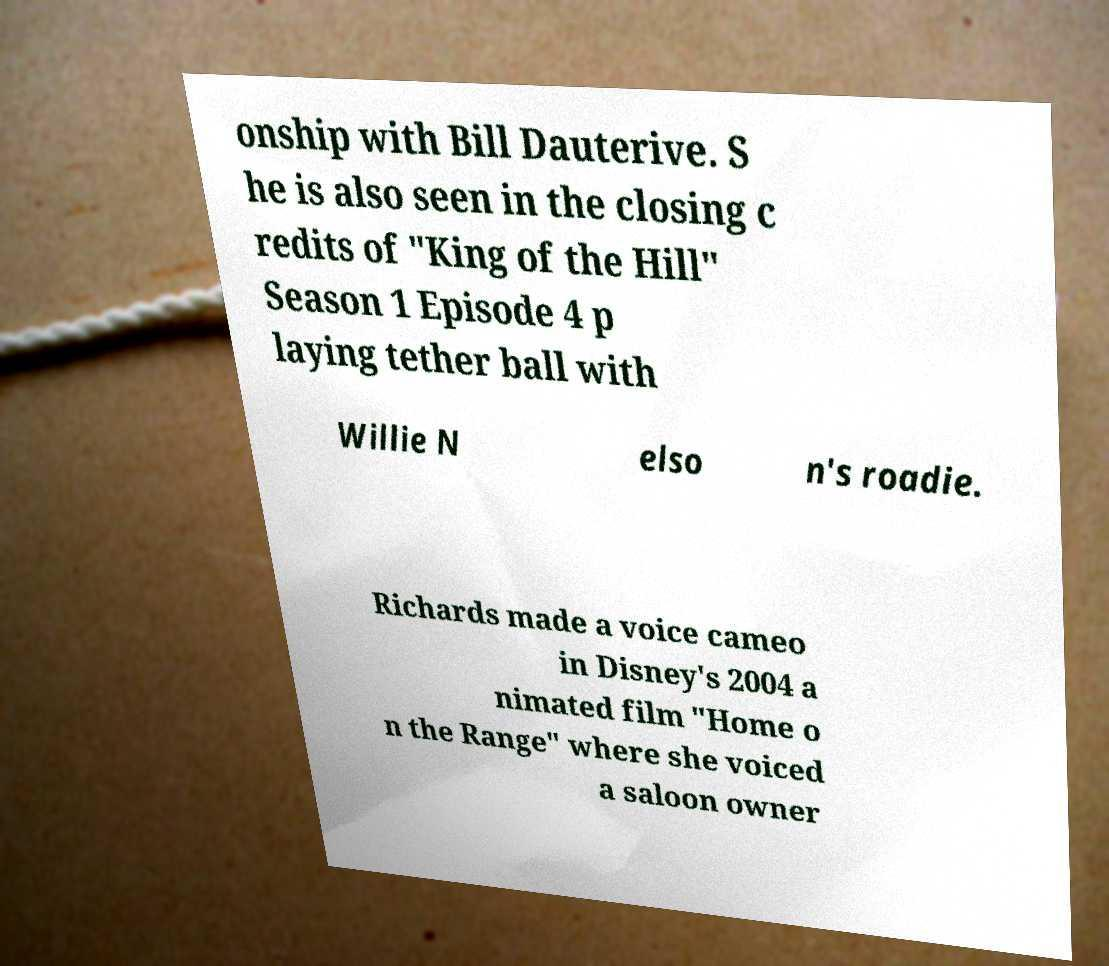I need the written content from this picture converted into text. Can you do that? onship with Bill Dauterive. S he is also seen in the closing c redits of "King of the Hill" Season 1 Episode 4 p laying tether ball with Willie N elso n's roadie. Richards made a voice cameo in Disney's 2004 a nimated film "Home o n the Range" where she voiced a saloon owner 